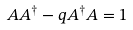<formula> <loc_0><loc_0><loc_500><loc_500>A A ^ { \dagger } - q A ^ { \dagger } A = 1</formula> 